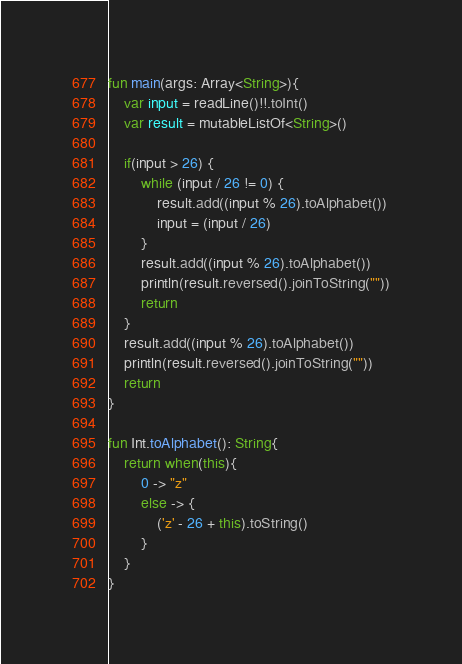Convert code to text. <code><loc_0><loc_0><loc_500><loc_500><_Kotlin_>fun main(args: Array<String>){
    var input = readLine()!!.toInt()
    var result = mutableListOf<String>()

    if(input > 26) {
        while (input / 26 != 0) {
            result.add((input % 26).toAlphabet())
            input = (input / 26)
        }
        result.add((input % 26).toAlphabet())
        println(result.reversed().joinToString(""))
        return
    }
    result.add((input % 26).toAlphabet())
    println(result.reversed().joinToString(""))
    return
}

fun Int.toAlphabet(): String{
    return when(this){
        0 -> "z"
        else -> {
            ('z' - 26 + this).toString()
        }
    }
}</code> 